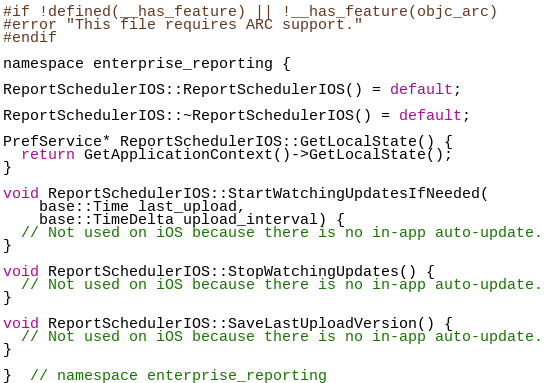Convert code to text. <code><loc_0><loc_0><loc_500><loc_500><_ObjectiveC_>
#if !defined(__has_feature) || !__has_feature(objc_arc)
#error "This file requires ARC support."
#endif

namespace enterprise_reporting {

ReportSchedulerIOS::ReportSchedulerIOS() = default;

ReportSchedulerIOS::~ReportSchedulerIOS() = default;

PrefService* ReportSchedulerIOS::GetLocalState() {
  return GetApplicationContext()->GetLocalState();
}

void ReportSchedulerIOS::StartWatchingUpdatesIfNeeded(
    base::Time last_upload,
    base::TimeDelta upload_interval) {
  // Not used on iOS because there is no in-app auto-update.
}

void ReportSchedulerIOS::StopWatchingUpdates() {
  // Not used on iOS because there is no in-app auto-update.
}

void ReportSchedulerIOS::SaveLastUploadVersion() {
  // Not used on iOS because there is no in-app auto-update.
}

}  // namespace enterprise_reporting
</code> 